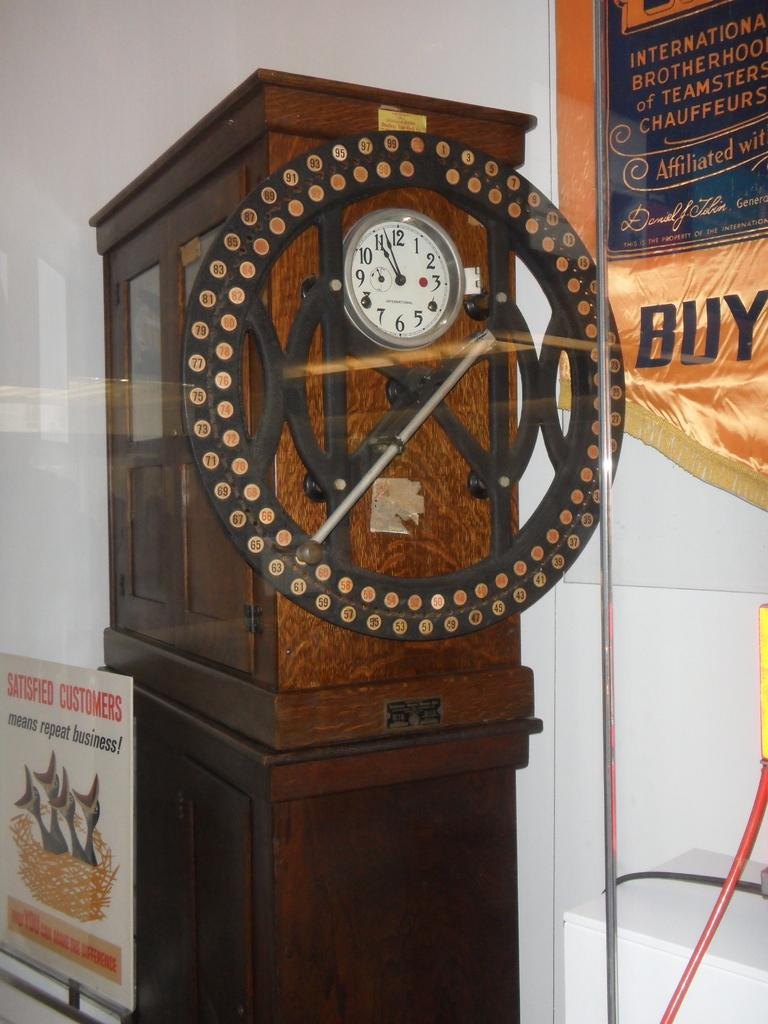Provide a one-sentence caption for the provided image. An unusual wooden clock on a wood pedestal displays a time of 11:55. 